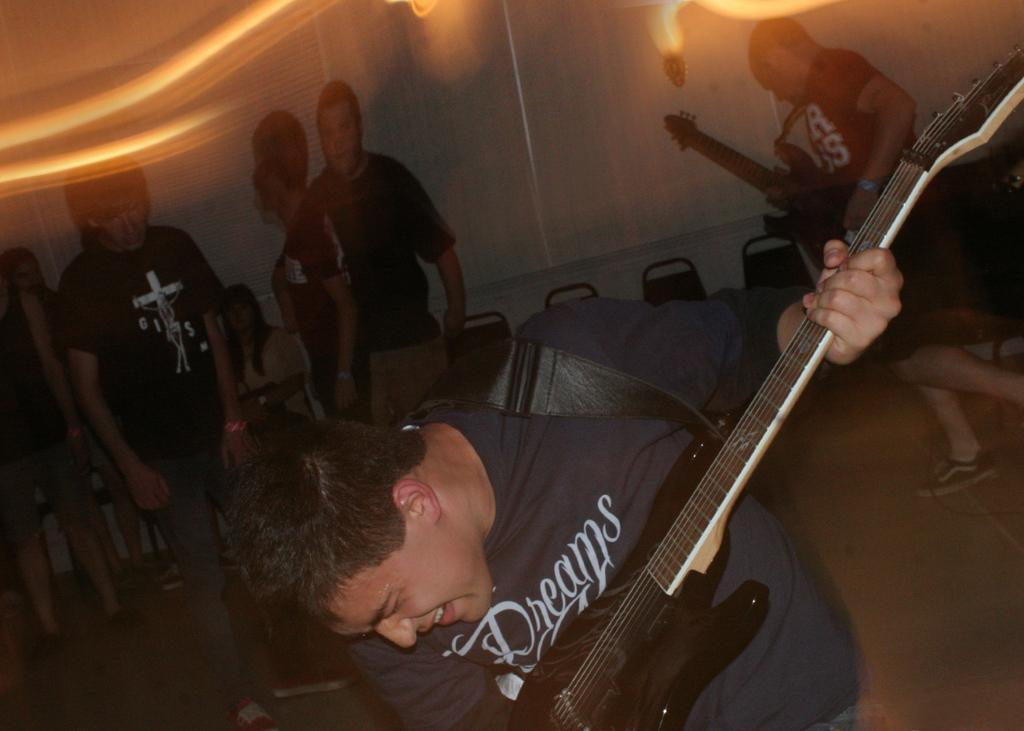How many persons are in the image? There are persons standing in the image, and one person is sitting on a chair, making a total of at least two persons. What are the persons holding in the image? Two persons are holding guitars in the image. What can be seen in the background of the image? There is a wall, a light, and chairs in the background of the image. What is visible on the floor in the image? The floor is visible in the image. What type of fruit can be seen growing on the grass in the image? There is no fruit or grass present in the image. What is the condition of the grass in the image? There is no grass present in the image, so it is not possible to determine its condition. 